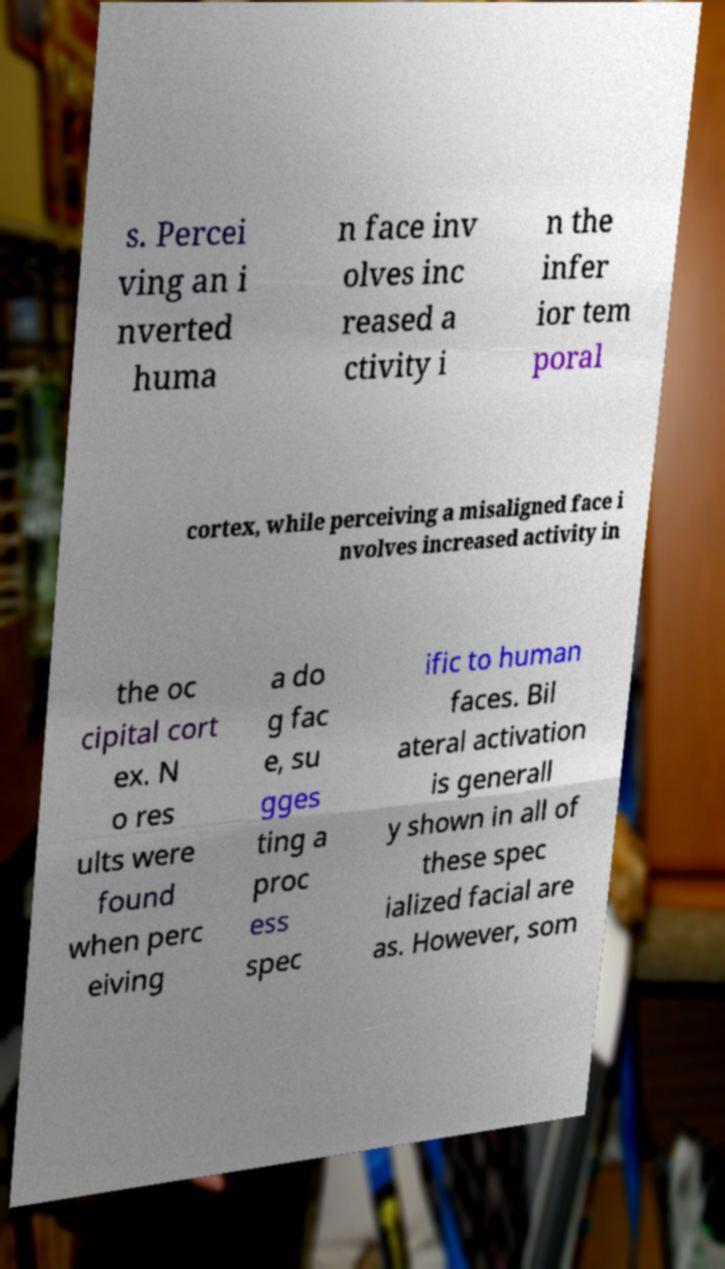There's text embedded in this image that I need extracted. Can you transcribe it verbatim? s. Percei ving an i nverted huma n face inv olves inc reased a ctivity i n the infer ior tem poral cortex, while perceiving a misaligned face i nvolves increased activity in the oc cipital cort ex. N o res ults were found when perc eiving a do g fac e, su gges ting a proc ess spec ific to human faces. Bil ateral activation is generall y shown in all of these spec ialized facial are as. However, som 